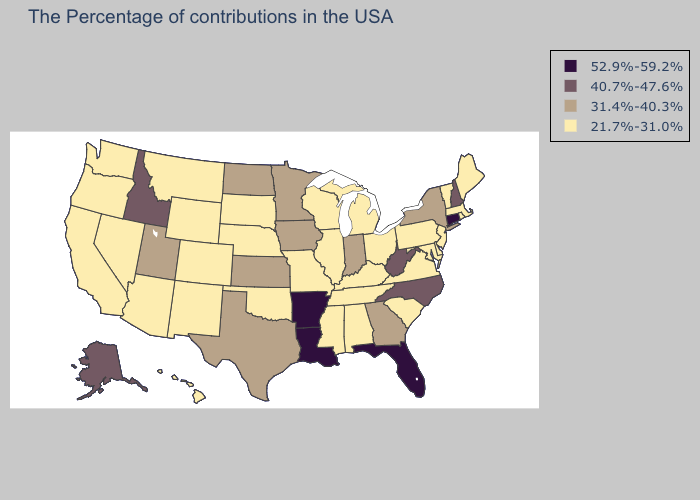Name the states that have a value in the range 21.7%-31.0%?
Short answer required. Maine, Massachusetts, Rhode Island, Vermont, New Jersey, Delaware, Maryland, Pennsylvania, Virginia, South Carolina, Ohio, Michigan, Kentucky, Alabama, Tennessee, Wisconsin, Illinois, Mississippi, Missouri, Nebraska, Oklahoma, South Dakota, Wyoming, Colorado, New Mexico, Montana, Arizona, Nevada, California, Washington, Oregon, Hawaii. Name the states that have a value in the range 21.7%-31.0%?
Short answer required. Maine, Massachusetts, Rhode Island, Vermont, New Jersey, Delaware, Maryland, Pennsylvania, Virginia, South Carolina, Ohio, Michigan, Kentucky, Alabama, Tennessee, Wisconsin, Illinois, Mississippi, Missouri, Nebraska, Oklahoma, South Dakota, Wyoming, Colorado, New Mexico, Montana, Arizona, Nevada, California, Washington, Oregon, Hawaii. What is the highest value in the USA?
Give a very brief answer. 52.9%-59.2%. Name the states that have a value in the range 31.4%-40.3%?
Give a very brief answer. New York, Georgia, Indiana, Minnesota, Iowa, Kansas, Texas, North Dakota, Utah. Does Arkansas have the highest value in the South?
Write a very short answer. Yes. Does Wisconsin have the same value as North Dakota?
Answer briefly. No. Which states have the highest value in the USA?
Answer briefly. Connecticut, Florida, Louisiana, Arkansas. Does New Mexico have the same value as Florida?
Give a very brief answer. No. Name the states that have a value in the range 31.4%-40.3%?
Quick response, please. New York, Georgia, Indiana, Minnesota, Iowa, Kansas, Texas, North Dakota, Utah. What is the lowest value in states that border Iowa?
Answer briefly. 21.7%-31.0%. Does the map have missing data?
Give a very brief answer. No. Name the states that have a value in the range 52.9%-59.2%?
Short answer required. Connecticut, Florida, Louisiana, Arkansas. What is the highest value in the Northeast ?
Quick response, please. 52.9%-59.2%. Is the legend a continuous bar?
Give a very brief answer. No. 